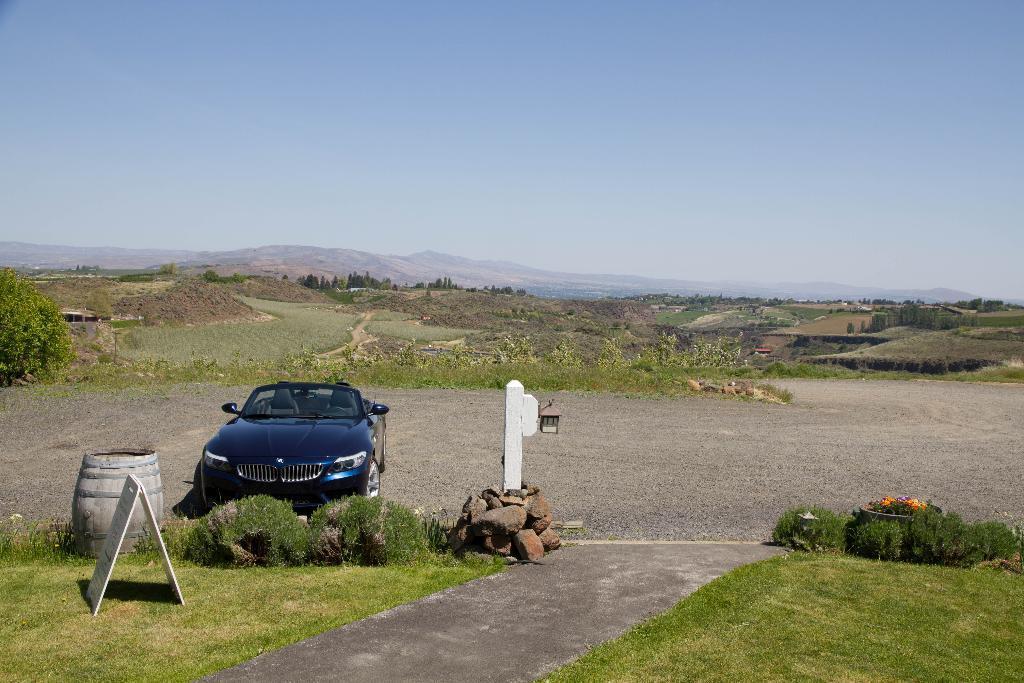In one or two sentences, can you explain what this image depicts? In this image we can see the car on the ground. And there are stones with wooden stick and light. And we can see the board, barrel, grass, trees, mountains and the sky. 